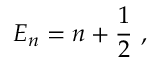Convert formula to latex. <formula><loc_0><loc_0><loc_500><loc_500>E _ { n } = n + { \frac { 1 } { 2 } } ,</formula> 